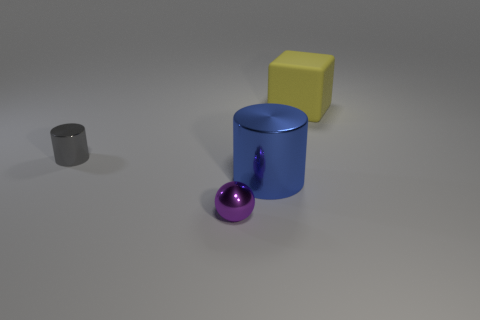What number of other things are there of the same material as the gray cylinder There are two objects that appear to be made of the same material as the gray cylinder, which includes a blue cylinder and a purple sphere. 